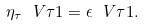<formula> <loc_0><loc_0><loc_500><loc_500>\eta _ { \tau } \ V { \tau } { 1 } = \epsilon \ V { \tau } { 1 } .</formula> 